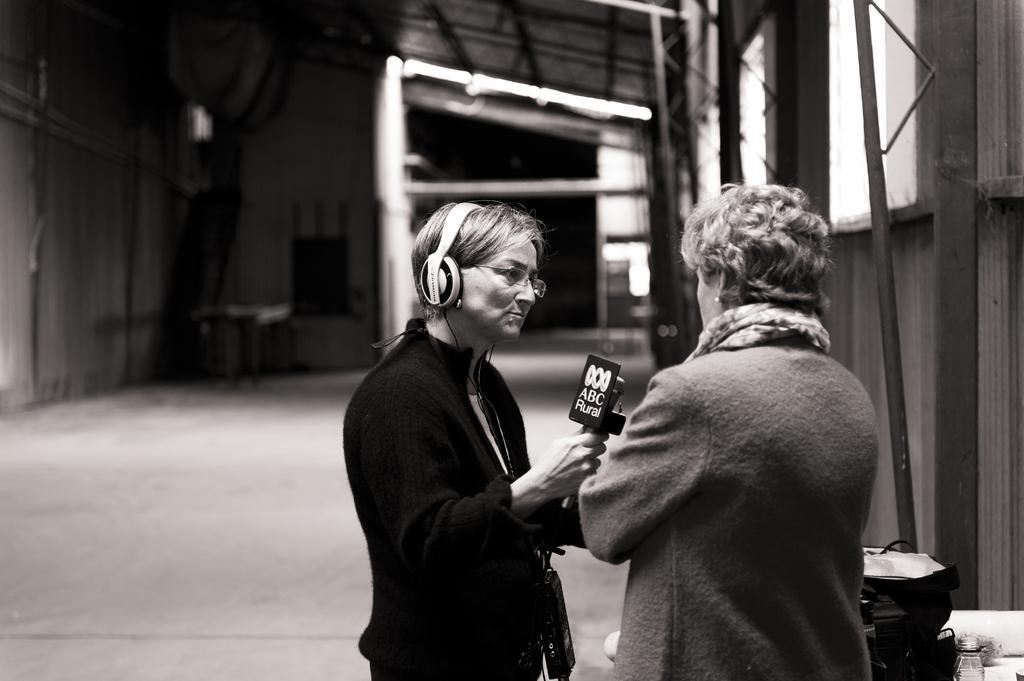Can you describe this image briefly? These two persons are standing and holding microphone wear headset,glasses. We can see bag on the floor. On the background we can see wall,windows. 